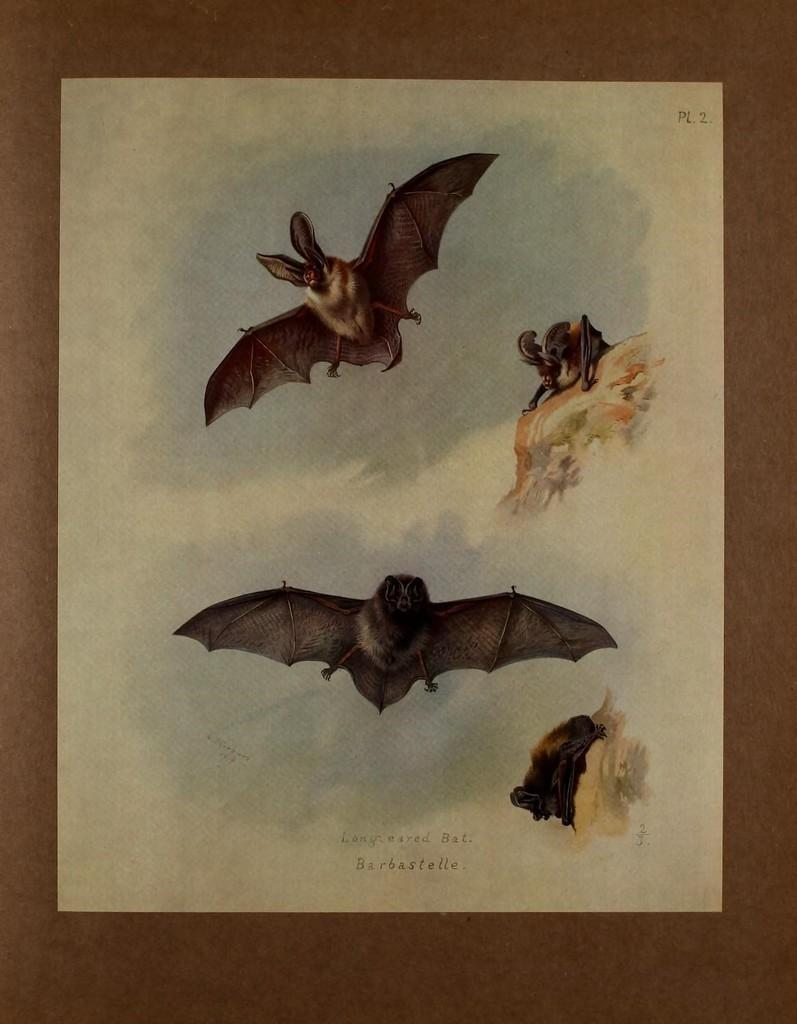What is present on the wooden platform in the image? There is a paper on the wooden platform in the image. What is depicted on the paper? The paper contains pictures of birds. Which direction is the glove pointing in the image? There is no glove present in the image. 